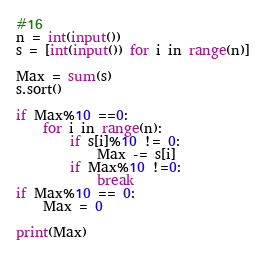Convert code to text. <code><loc_0><loc_0><loc_500><loc_500><_Python_>#16
n = int(input())
s = [int(input()) for i in range(n)]

Max = sum(s)
s.sort()

if Max%10 ==0:
    for i in range(n):
        if s[i]%10 != 0:
            Max -= s[i]
        if Max%10 !=0:
            break
if Max%10 == 0:
    Max = 0
    
print(Max)</code> 